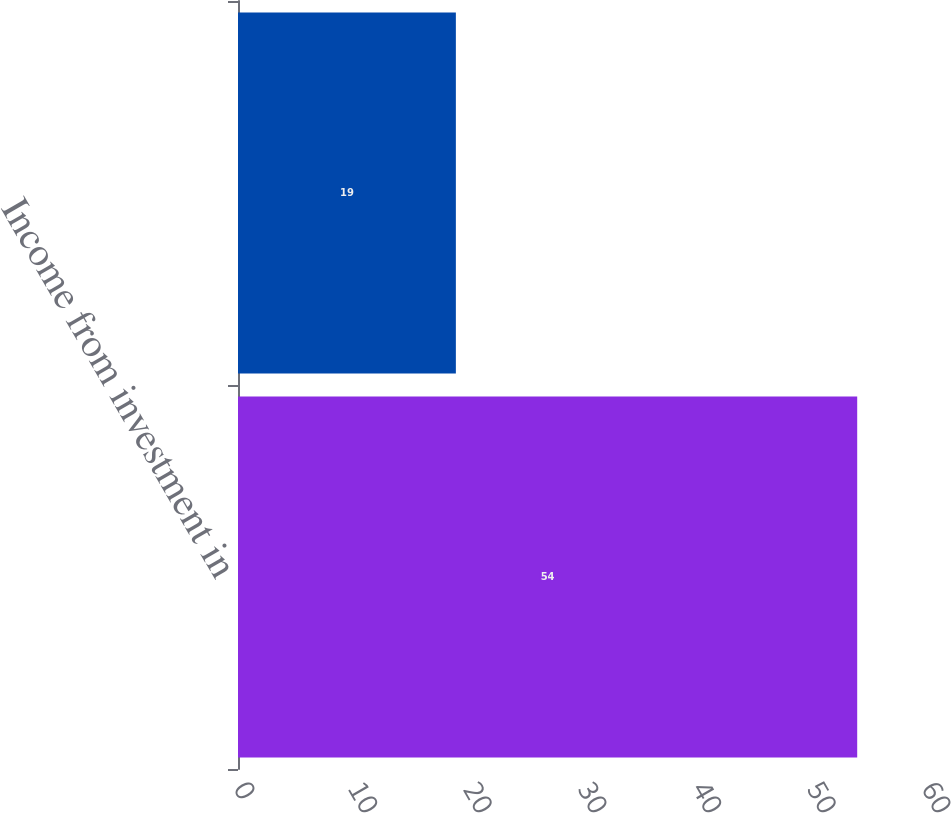Convert chart. <chart><loc_0><loc_0><loc_500><loc_500><bar_chart><fcel>Income from investment in<fcel>Unnamed: 1<nl><fcel>54<fcel>19<nl></chart> 